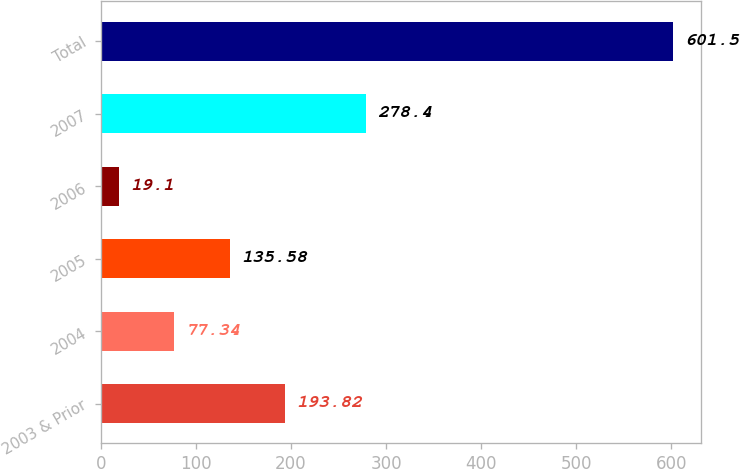Convert chart. <chart><loc_0><loc_0><loc_500><loc_500><bar_chart><fcel>2003 & Prior<fcel>2004<fcel>2005<fcel>2006<fcel>2007<fcel>Total<nl><fcel>193.82<fcel>77.34<fcel>135.58<fcel>19.1<fcel>278.4<fcel>601.5<nl></chart> 